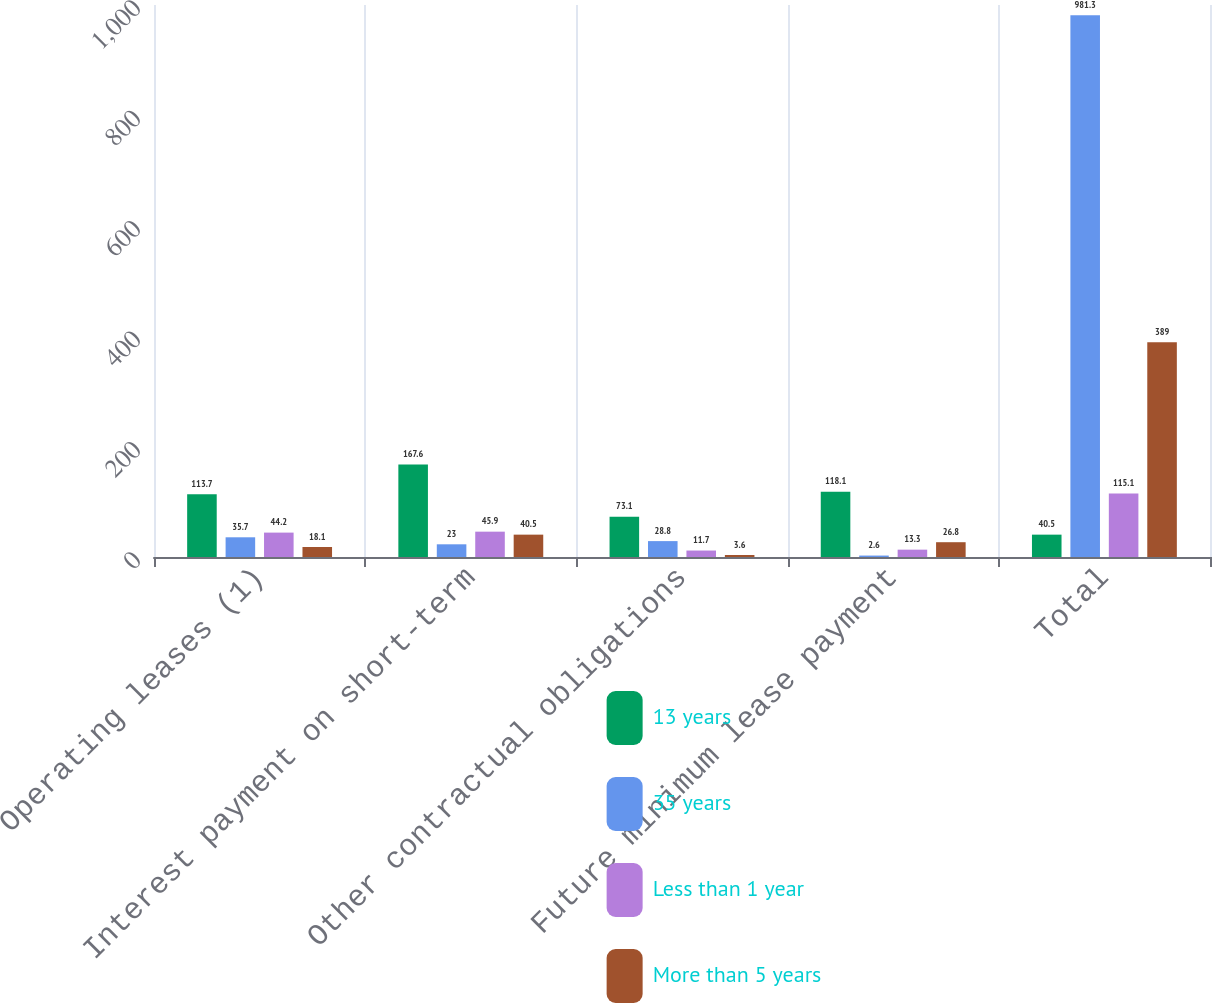Convert chart. <chart><loc_0><loc_0><loc_500><loc_500><stacked_bar_chart><ecel><fcel>Operating leases (1)<fcel>Interest payment on short-term<fcel>Other contractual obligations<fcel>Future minimum lease payment<fcel>Total<nl><fcel>13 years<fcel>113.7<fcel>167.6<fcel>73.1<fcel>118.1<fcel>40.5<nl><fcel>35 years<fcel>35.7<fcel>23<fcel>28.8<fcel>2.6<fcel>981.3<nl><fcel>Less than 1 year<fcel>44.2<fcel>45.9<fcel>11.7<fcel>13.3<fcel>115.1<nl><fcel>More than 5 years<fcel>18.1<fcel>40.5<fcel>3.6<fcel>26.8<fcel>389<nl></chart> 